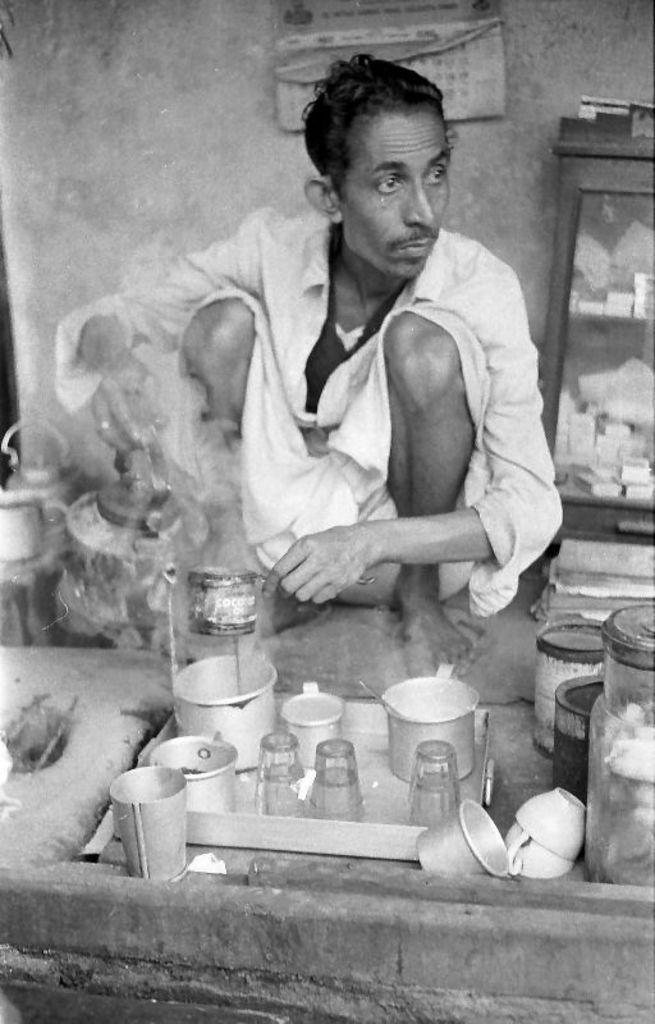Please provide a concise description of this image. In this picture there is a man who is wearing white dress and locket. He is in squat position. He is making a tea and holding a cup and bowl. On the bottom we can see tea cups, glass, jug, steel glass, cans and other objects. On the top there is a calendar on the wall. On the right we can see a cupboard on which we can see some cotton boxes and papers. 